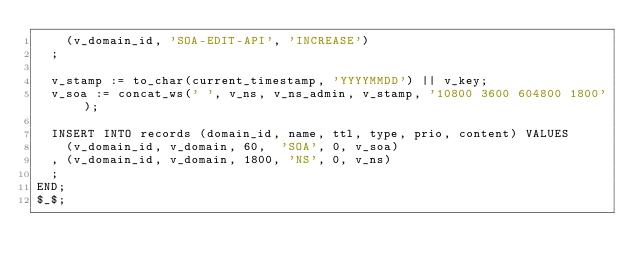Convert code to text. <code><loc_0><loc_0><loc_500><loc_500><_SQL_>    (v_domain_id, 'SOA-EDIT-API', 'INCREASE')
  ;

  v_stamp := to_char(current_timestamp, 'YYYYMMDD') || v_key;
  v_soa := concat_ws(' ', v_ns, v_ns_admin, v_stamp, '10800 3600 604800 1800');

  INSERT INTO records (domain_id, name, ttl, type, prio, content) VALUES 
    (v_domain_id, v_domain, 60,  'SOA', 0, v_soa)
  , (v_domain_id, v_domain, 1800, 'NS', 0, v_ns)
  ;
END;
$_$;
</code> 